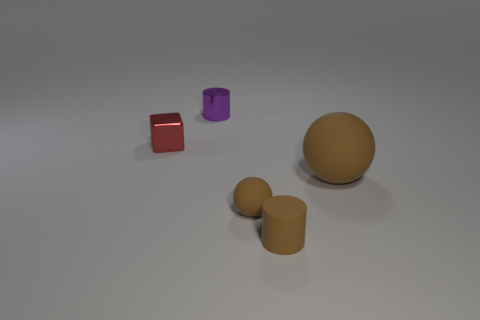Add 3 purple objects. How many objects exist? 8 Subtract all blocks. How many objects are left? 4 Add 4 brown cylinders. How many brown cylinders are left? 5 Add 5 matte spheres. How many matte spheres exist? 7 Subtract 0 gray cubes. How many objects are left? 5 Subtract all cyan metallic cylinders. Subtract all tiny cylinders. How many objects are left? 3 